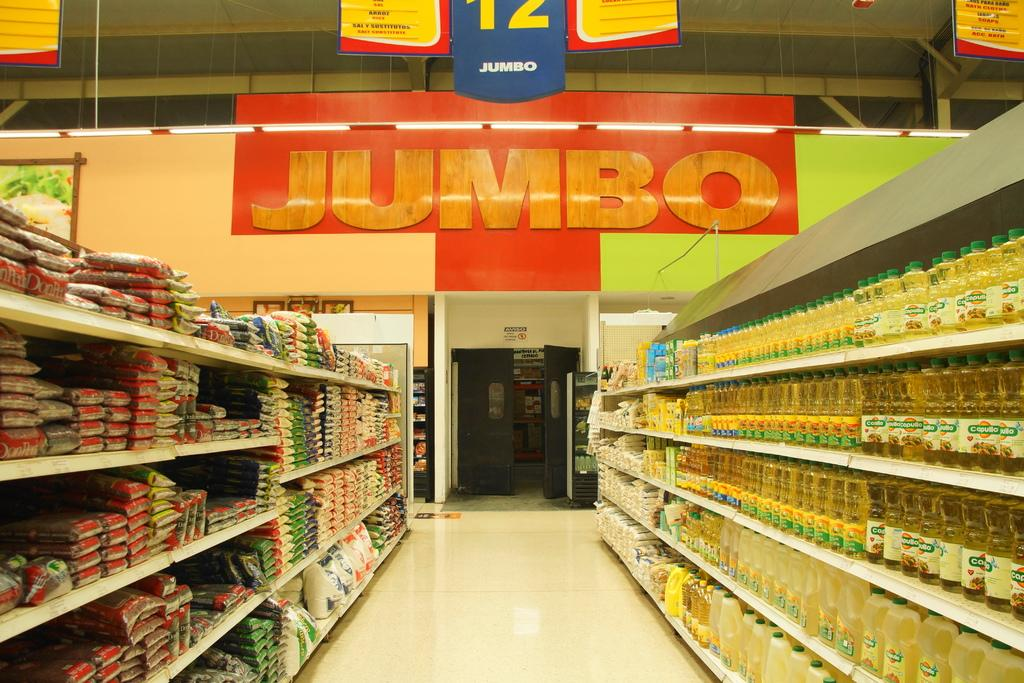<image>
Present a compact description of the photo's key features. A red sign with Jumbo on it hands at the back of the aisles. 